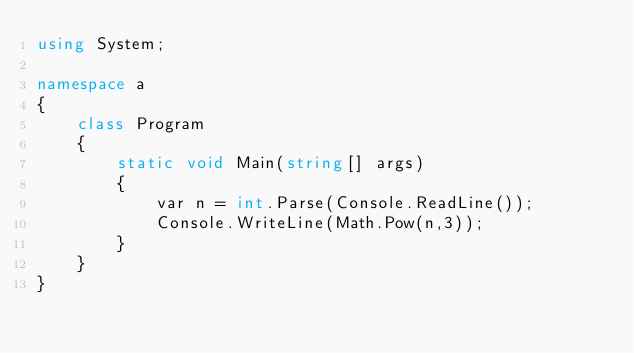Convert code to text. <code><loc_0><loc_0><loc_500><loc_500><_C#_>using System;

namespace a
{
    class Program
    {
        static void Main(string[] args)
        {
            var n = int.Parse(Console.ReadLine());
            Console.WriteLine(Math.Pow(n,3));
        }
    }
}
</code> 